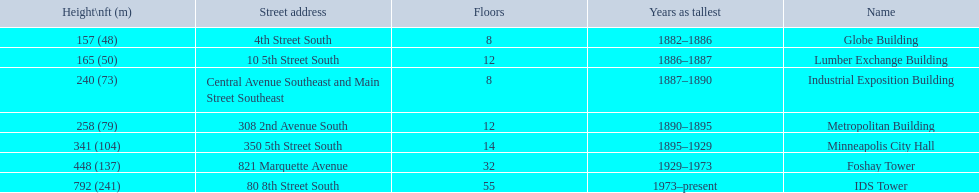How many floors does the globe building have? 8. Which building has 14 floors? Minneapolis City Hall. The lumber exchange building has the same number of floors as which building? Metropolitan Building. 